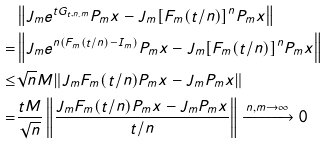<formula> <loc_0><loc_0><loc_500><loc_500>& \left \| J _ { m } e ^ { t G _ { t , n . m } } P _ { m } x - J _ { m } [ F _ { m } ( t / n ) ] ^ { n } P _ { m } x \right \| \\ = & \left \| J _ { m } e ^ { n ( F _ { m } ( t / n ) - I _ { m } ) } P _ { m } x - J _ { m } [ F _ { m } ( t / n ) ] ^ { n } P _ { m } x \right \| \\ \leq & \sqrt { n } M \| J _ { m } F _ { m } ( t / n ) P _ { m } x - J _ { m } P _ { m } x \| \\ = & \frac { t M } { \sqrt { n } } \left \| \frac { J _ { m } F _ { m } ( t / n ) P _ { m } x - J _ { m } P _ { m } x } { t / n } \right \| \xrightarrow { n , m \to \infty } 0</formula> 